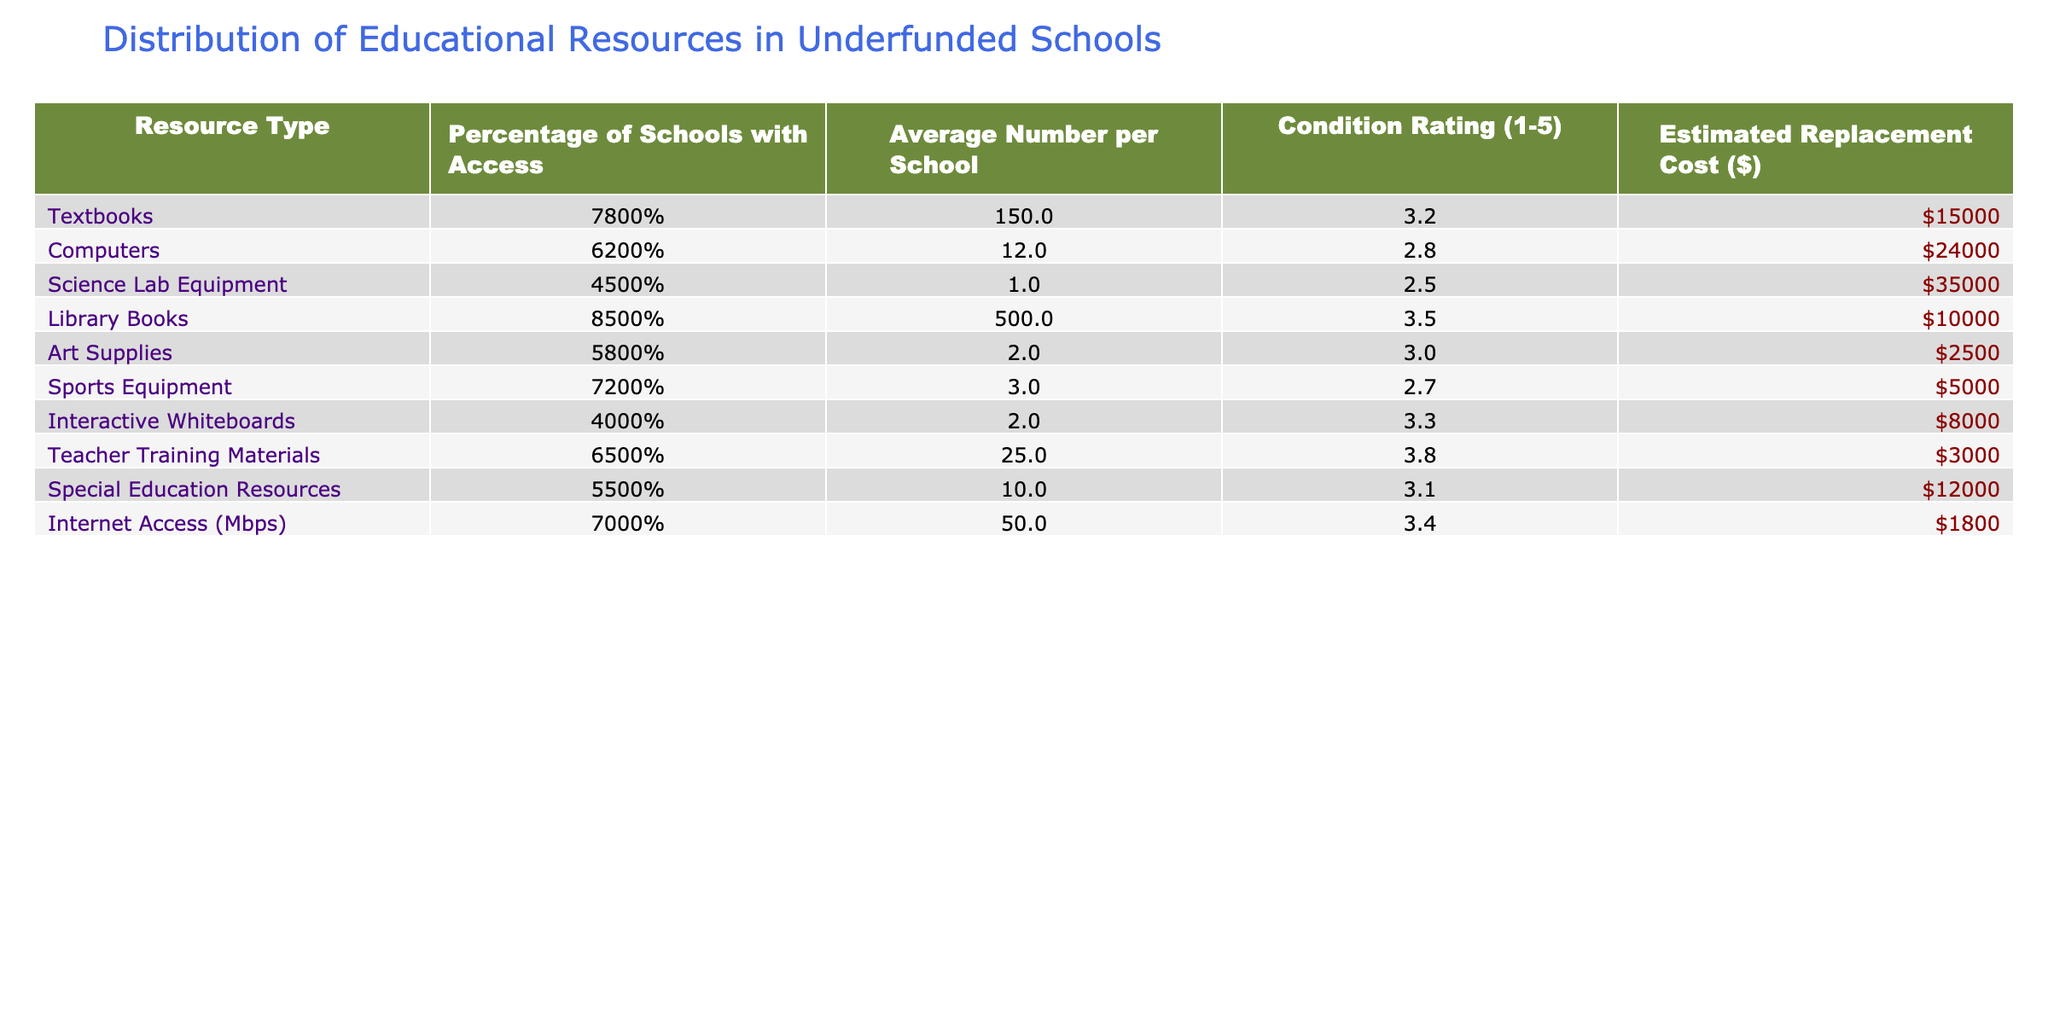What percentage of schools have access to library books? The table shows that 85% of schools have access to library books. This is clearly indicated under the "Percentage of Schools with Access" column for "Library Books."
Answer: 85% What is the average number of textbooks available per school? According to the table, the average number of textbooks per school is listed as 150. This value is found in the "Average Number per School" column for "Textbooks."
Answer: 150 How does the condition rating of computers compare to that of sports equipment? The condition rating for computers is 2.8, while for sports equipment, it is 2.7. This indicates that computers have a slightly better condition rating than sports equipment.
Answer: Computers have a better condition rating What is the estimated replacement cost of science lab equipment? The estimated replacement cost for science lab equipment is $35,000, as specified in the "Estimated Replacement Cost ($)" column for "Science Lab Equipment."
Answer: $35000 What resource type has the highest percentage of schools with access? The highest percentage of schools with access is for library books at 85%. This is the highest percentage listed in the "Percentage of Schools with Access" column.
Answer: Library Books What is the average condition rating of textbooks and special education resources combined? The condition rating for textbooks is 3.2, and for special education resources, it’s 3.1. Adding these values gives 3.2 + 3.1 = 6.3. Then, dividing by 2 for the average gives 6.3 / 2 = 3.15.
Answer: 3.15 Is the percentage of schools with access to interactive whiteboards greater than 50%? The percentage of schools with access to interactive whiteboards is 40%, which is less than 50%. Therefore, the statement is false.
Answer: No If you rank the resource types by estimated replacement cost, which resource type is the most expensive? The estimated replacement costs listed show that "Science Lab Equipment" has the highest cost at $35,000. We can observe this by comparing costs in the "Estimated Replacement Cost ($)" column.
Answer: Science Lab Equipment What is the difference in average number of computers and average number of art supplies per school? The average number of computers per school is 12, and the average number of art supplies is 2. The difference is calculated as 12 - 2 = 10.
Answer: 10 Which resource has the lowest average number available per school? The resource with the lowest average number available per school is "Science Lab Equipment" with an average of 1. This is identified in the "Average Number per School" column.
Answer: Science Lab Equipment 